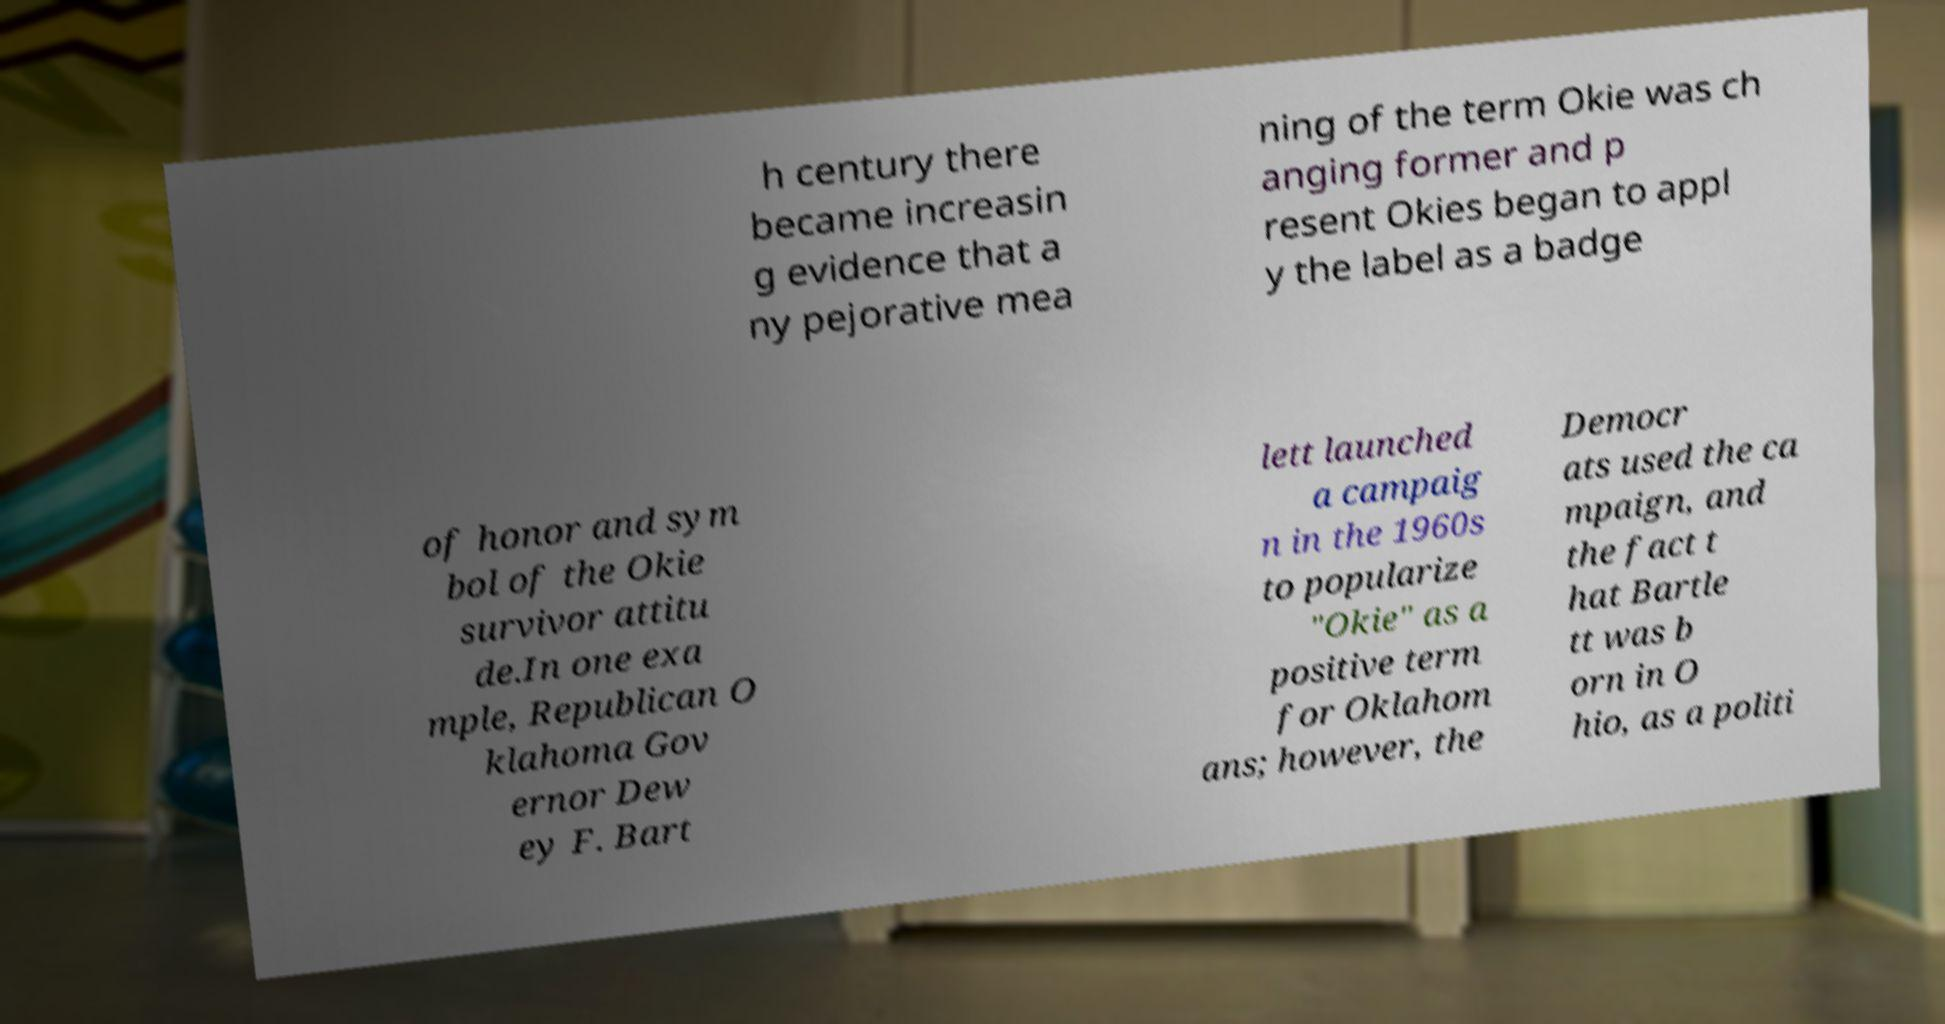Please identify and transcribe the text found in this image. h century there became increasin g evidence that a ny pejorative mea ning of the term Okie was ch anging former and p resent Okies began to appl y the label as a badge of honor and sym bol of the Okie survivor attitu de.In one exa mple, Republican O klahoma Gov ernor Dew ey F. Bart lett launched a campaig n in the 1960s to popularize "Okie" as a positive term for Oklahom ans; however, the Democr ats used the ca mpaign, and the fact t hat Bartle tt was b orn in O hio, as a politi 